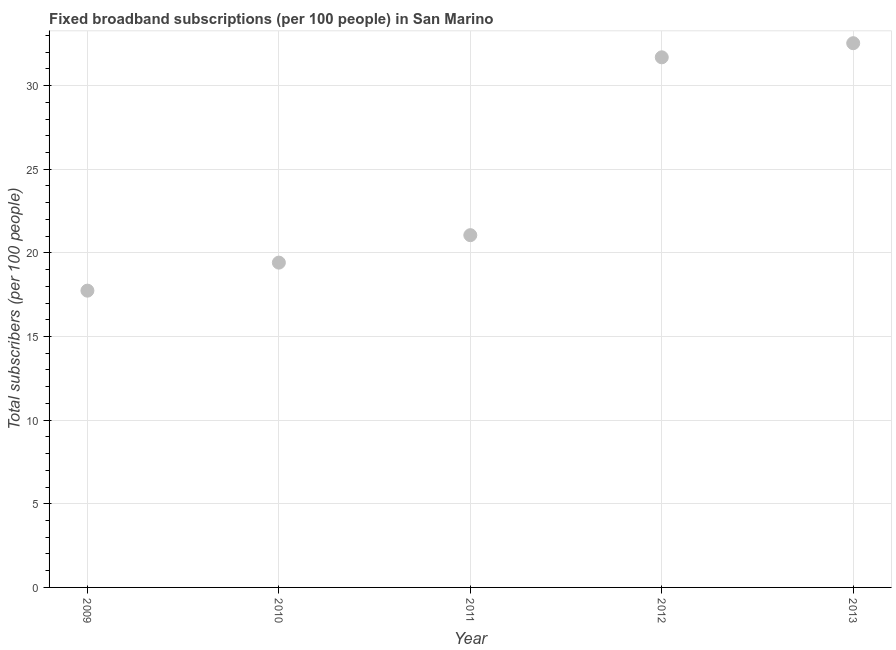What is the total number of fixed broadband subscriptions in 2011?
Make the answer very short. 21.06. Across all years, what is the maximum total number of fixed broadband subscriptions?
Provide a succinct answer. 32.53. Across all years, what is the minimum total number of fixed broadband subscriptions?
Provide a short and direct response. 17.74. What is the sum of the total number of fixed broadband subscriptions?
Your answer should be very brief. 122.44. What is the difference between the total number of fixed broadband subscriptions in 2010 and 2013?
Provide a succinct answer. -13.12. What is the average total number of fixed broadband subscriptions per year?
Keep it short and to the point. 24.49. What is the median total number of fixed broadband subscriptions?
Your answer should be compact. 21.06. In how many years, is the total number of fixed broadband subscriptions greater than 21 ?
Offer a very short reply. 3. Do a majority of the years between 2009 and 2011 (inclusive) have total number of fixed broadband subscriptions greater than 18 ?
Your response must be concise. Yes. What is the ratio of the total number of fixed broadband subscriptions in 2010 to that in 2011?
Your response must be concise. 0.92. Is the total number of fixed broadband subscriptions in 2009 less than that in 2010?
Your answer should be very brief. Yes. What is the difference between the highest and the second highest total number of fixed broadband subscriptions?
Offer a terse response. 0.84. What is the difference between the highest and the lowest total number of fixed broadband subscriptions?
Ensure brevity in your answer.  14.79. Does the total number of fixed broadband subscriptions monotonically increase over the years?
Provide a succinct answer. Yes. How many dotlines are there?
Ensure brevity in your answer.  1. How many years are there in the graph?
Ensure brevity in your answer.  5. What is the difference between two consecutive major ticks on the Y-axis?
Offer a terse response. 5. What is the title of the graph?
Keep it short and to the point. Fixed broadband subscriptions (per 100 people) in San Marino. What is the label or title of the Y-axis?
Your answer should be very brief. Total subscribers (per 100 people). What is the Total subscribers (per 100 people) in 2009?
Keep it short and to the point. 17.74. What is the Total subscribers (per 100 people) in 2010?
Provide a succinct answer. 19.42. What is the Total subscribers (per 100 people) in 2011?
Offer a terse response. 21.06. What is the Total subscribers (per 100 people) in 2012?
Keep it short and to the point. 31.69. What is the Total subscribers (per 100 people) in 2013?
Your answer should be compact. 32.53. What is the difference between the Total subscribers (per 100 people) in 2009 and 2010?
Offer a terse response. -1.68. What is the difference between the Total subscribers (per 100 people) in 2009 and 2011?
Offer a terse response. -3.32. What is the difference between the Total subscribers (per 100 people) in 2009 and 2012?
Offer a very short reply. -13.95. What is the difference between the Total subscribers (per 100 people) in 2009 and 2013?
Keep it short and to the point. -14.79. What is the difference between the Total subscribers (per 100 people) in 2010 and 2011?
Provide a succinct answer. -1.64. What is the difference between the Total subscribers (per 100 people) in 2010 and 2012?
Your response must be concise. -12.27. What is the difference between the Total subscribers (per 100 people) in 2010 and 2013?
Ensure brevity in your answer.  -13.12. What is the difference between the Total subscribers (per 100 people) in 2011 and 2012?
Make the answer very short. -10.63. What is the difference between the Total subscribers (per 100 people) in 2011 and 2013?
Offer a very short reply. -11.48. What is the difference between the Total subscribers (per 100 people) in 2012 and 2013?
Make the answer very short. -0.84. What is the ratio of the Total subscribers (per 100 people) in 2009 to that in 2010?
Make the answer very short. 0.91. What is the ratio of the Total subscribers (per 100 people) in 2009 to that in 2011?
Provide a succinct answer. 0.84. What is the ratio of the Total subscribers (per 100 people) in 2009 to that in 2012?
Give a very brief answer. 0.56. What is the ratio of the Total subscribers (per 100 people) in 2009 to that in 2013?
Provide a succinct answer. 0.55. What is the ratio of the Total subscribers (per 100 people) in 2010 to that in 2011?
Your answer should be very brief. 0.92. What is the ratio of the Total subscribers (per 100 people) in 2010 to that in 2012?
Offer a terse response. 0.61. What is the ratio of the Total subscribers (per 100 people) in 2010 to that in 2013?
Give a very brief answer. 0.6. What is the ratio of the Total subscribers (per 100 people) in 2011 to that in 2012?
Provide a short and direct response. 0.67. What is the ratio of the Total subscribers (per 100 people) in 2011 to that in 2013?
Ensure brevity in your answer.  0.65. 